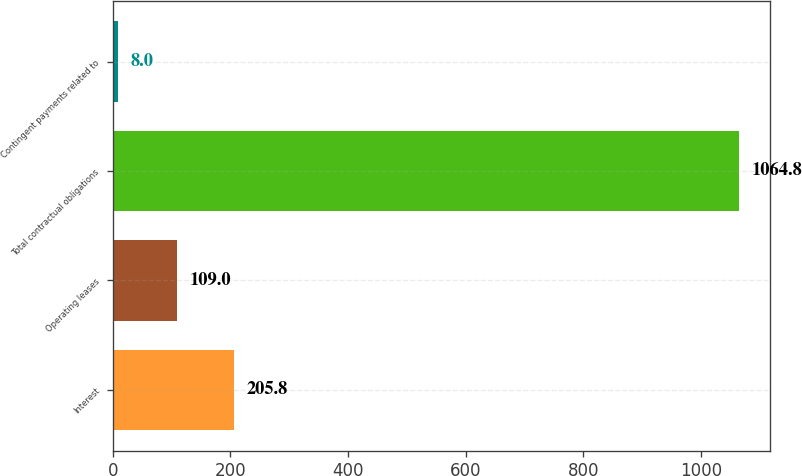Convert chart. <chart><loc_0><loc_0><loc_500><loc_500><bar_chart><fcel>Interest<fcel>Operating leases<fcel>Total contractual obligations<fcel>Contingent payments related to<nl><fcel>205.8<fcel>109<fcel>1064.8<fcel>8<nl></chart> 